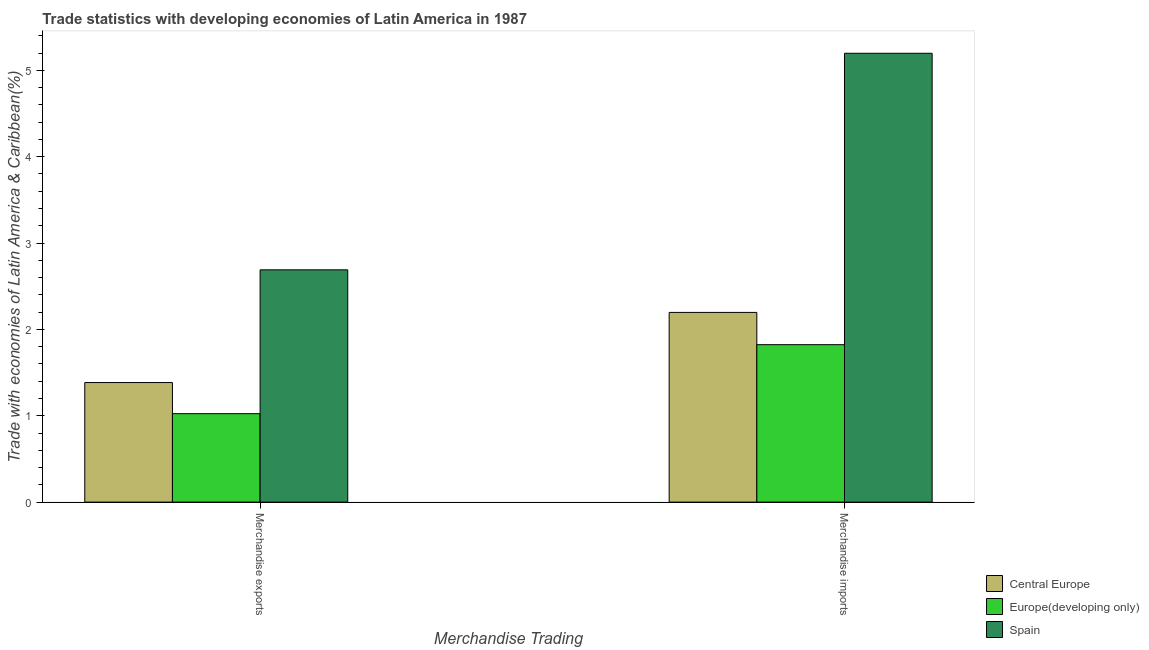How many different coloured bars are there?
Make the answer very short. 3. How many groups of bars are there?
Ensure brevity in your answer.  2. Are the number of bars per tick equal to the number of legend labels?
Provide a short and direct response. Yes. How many bars are there on the 2nd tick from the left?
Give a very brief answer. 3. What is the merchandise exports in Central Europe?
Give a very brief answer. 1.38. Across all countries, what is the maximum merchandise exports?
Your answer should be very brief. 2.69. Across all countries, what is the minimum merchandise imports?
Offer a very short reply. 1.82. In which country was the merchandise imports maximum?
Offer a very short reply. Spain. In which country was the merchandise exports minimum?
Offer a terse response. Europe(developing only). What is the total merchandise exports in the graph?
Keep it short and to the point. 5.1. What is the difference between the merchandise imports in Europe(developing only) and that in Central Europe?
Offer a very short reply. -0.37. What is the difference between the merchandise imports in Central Europe and the merchandise exports in Spain?
Ensure brevity in your answer.  -0.49. What is the average merchandise exports per country?
Keep it short and to the point. 1.7. What is the difference between the merchandise exports and merchandise imports in Spain?
Provide a succinct answer. -2.51. What is the ratio of the merchandise imports in Spain to that in Europe(developing only)?
Make the answer very short. 2.85. In how many countries, is the merchandise imports greater than the average merchandise imports taken over all countries?
Make the answer very short. 1. What does the 3rd bar from the left in Merchandise imports represents?
Give a very brief answer. Spain. What does the 2nd bar from the right in Merchandise exports represents?
Offer a terse response. Europe(developing only). How many bars are there?
Your response must be concise. 6. What is the difference between two consecutive major ticks on the Y-axis?
Give a very brief answer. 1. Does the graph contain any zero values?
Keep it short and to the point. No. How are the legend labels stacked?
Ensure brevity in your answer.  Vertical. What is the title of the graph?
Give a very brief answer. Trade statistics with developing economies of Latin America in 1987. What is the label or title of the X-axis?
Provide a succinct answer. Merchandise Trading. What is the label or title of the Y-axis?
Your answer should be compact. Trade with economies of Latin America & Caribbean(%). What is the Trade with economies of Latin America & Caribbean(%) in Central Europe in Merchandise exports?
Your response must be concise. 1.38. What is the Trade with economies of Latin America & Caribbean(%) of Europe(developing only) in Merchandise exports?
Provide a short and direct response. 1.02. What is the Trade with economies of Latin America & Caribbean(%) of Spain in Merchandise exports?
Ensure brevity in your answer.  2.69. What is the Trade with economies of Latin America & Caribbean(%) of Central Europe in Merchandise imports?
Ensure brevity in your answer.  2.2. What is the Trade with economies of Latin America & Caribbean(%) of Europe(developing only) in Merchandise imports?
Your answer should be compact. 1.82. What is the Trade with economies of Latin America & Caribbean(%) of Spain in Merchandise imports?
Give a very brief answer. 5.2. Across all Merchandise Trading, what is the maximum Trade with economies of Latin America & Caribbean(%) in Central Europe?
Your answer should be compact. 2.2. Across all Merchandise Trading, what is the maximum Trade with economies of Latin America & Caribbean(%) in Europe(developing only)?
Your answer should be very brief. 1.82. Across all Merchandise Trading, what is the maximum Trade with economies of Latin America & Caribbean(%) of Spain?
Your answer should be compact. 5.2. Across all Merchandise Trading, what is the minimum Trade with economies of Latin America & Caribbean(%) of Central Europe?
Provide a short and direct response. 1.38. Across all Merchandise Trading, what is the minimum Trade with economies of Latin America & Caribbean(%) of Europe(developing only)?
Offer a terse response. 1.02. Across all Merchandise Trading, what is the minimum Trade with economies of Latin America & Caribbean(%) in Spain?
Give a very brief answer. 2.69. What is the total Trade with economies of Latin America & Caribbean(%) in Central Europe in the graph?
Provide a short and direct response. 3.58. What is the total Trade with economies of Latin America & Caribbean(%) in Europe(developing only) in the graph?
Provide a short and direct response. 2.85. What is the total Trade with economies of Latin America & Caribbean(%) of Spain in the graph?
Keep it short and to the point. 7.89. What is the difference between the Trade with economies of Latin America & Caribbean(%) of Central Europe in Merchandise exports and that in Merchandise imports?
Offer a very short reply. -0.81. What is the difference between the Trade with economies of Latin America & Caribbean(%) of Europe(developing only) in Merchandise exports and that in Merchandise imports?
Make the answer very short. -0.8. What is the difference between the Trade with economies of Latin America & Caribbean(%) of Spain in Merchandise exports and that in Merchandise imports?
Keep it short and to the point. -2.51. What is the difference between the Trade with economies of Latin America & Caribbean(%) in Central Europe in Merchandise exports and the Trade with economies of Latin America & Caribbean(%) in Europe(developing only) in Merchandise imports?
Your answer should be very brief. -0.44. What is the difference between the Trade with economies of Latin America & Caribbean(%) of Central Europe in Merchandise exports and the Trade with economies of Latin America & Caribbean(%) of Spain in Merchandise imports?
Offer a terse response. -3.81. What is the difference between the Trade with economies of Latin America & Caribbean(%) in Europe(developing only) in Merchandise exports and the Trade with economies of Latin America & Caribbean(%) in Spain in Merchandise imports?
Your answer should be compact. -4.17. What is the average Trade with economies of Latin America & Caribbean(%) of Central Europe per Merchandise Trading?
Your answer should be very brief. 1.79. What is the average Trade with economies of Latin America & Caribbean(%) in Europe(developing only) per Merchandise Trading?
Your answer should be very brief. 1.42. What is the average Trade with economies of Latin America & Caribbean(%) of Spain per Merchandise Trading?
Make the answer very short. 3.94. What is the difference between the Trade with economies of Latin America & Caribbean(%) in Central Europe and Trade with economies of Latin America & Caribbean(%) in Europe(developing only) in Merchandise exports?
Keep it short and to the point. 0.36. What is the difference between the Trade with economies of Latin America & Caribbean(%) of Central Europe and Trade with economies of Latin America & Caribbean(%) of Spain in Merchandise exports?
Keep it short and to the point. -1.31. What is the difference between the Trade with economies of Latin America & Caribbean(%) of Europe(developing only) and Trade with economies of Latin America & Caribbean(%) of Spain in Merchandise exports?
Provide a succinct answer. -1.67. What is the difference between the Trade with economies of Latin America & Caribbean(%) of Central Europe and Trade with economies of Latin America & Caribbean(%) of Europe(developing only) in Merchandise imports?
Provide a short and direct response. 0.37. What is the difference between the Trade with economies of Latin America & Caribbean(%) of Central Europe and Trade with economies of Latin America & Caribbean(%) of Spain in Merchandise imports?
Provide a succinct answer. -3. What is the difference between the Trade with economies of Latin America & Caribbean(%) in Europe(developing only) and Trade with economies of Latin America & Caribbean(%) in Spain in Merchandise imports?
Your response must be concise. -3.37. What is the ratio of the Trade with economies of Latin America & Caribbean(%) in Central Europe in Merchandise exports to that in Merchandise imports?
Offer a terse response. 0.63. What is the ratio of the Trade with economies of Latin America & Caribbean(%) in Europe(developing only) in Merchandise exports to that in Merchandise imports?
Keep it short and to the point. 0.56. What is the ratio of the Trade with economies of Latin America & Caribbean(%) of Spain in Merchandise exports to that in Merchandise imports?
Your answer should be very brief. 0.52. What is the difference between the highest and the second highest Trade with economies of Latin America & Caribbean(%) of Central Europe?
Make the answer very short. 0.81. What is the difference between the highest and the second highest Trade with economies of Latin America & Caribbean(%) in Europe(developing only)?
Offer a very short reply. 0.8. What is the difference between the highest and the second highest Trade with economies of Latin America & Caribbean(%) of Spain?
Provide a succinct answer. 2.51. What is the difference between the highest and the lowest Trade with economies of Latin America & Caribbean(%) in Central Europe?
Your answer should be compact. 0.81. What is the difference between the highest and the lowest Trade with economies of Latin America & Caribbean(%) of Europe(developing only)?
Ensure brevity in your answer.  0.8. What is the difference between the highest and the lowest Trade with economies of Latin America & Caribbean(%) in Spain?
Give a very brief answer. 2.51. 